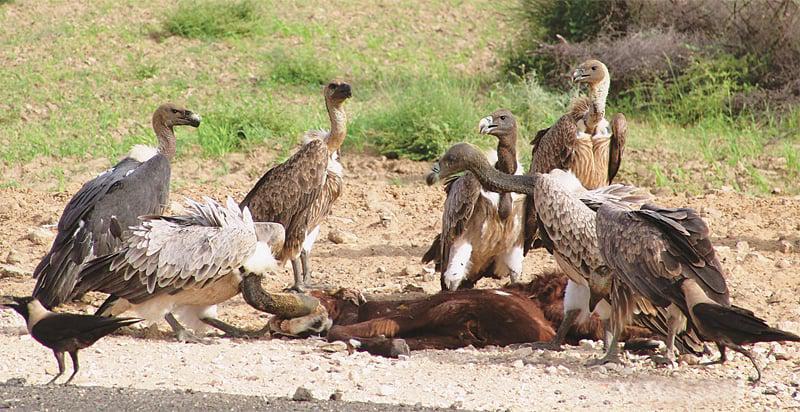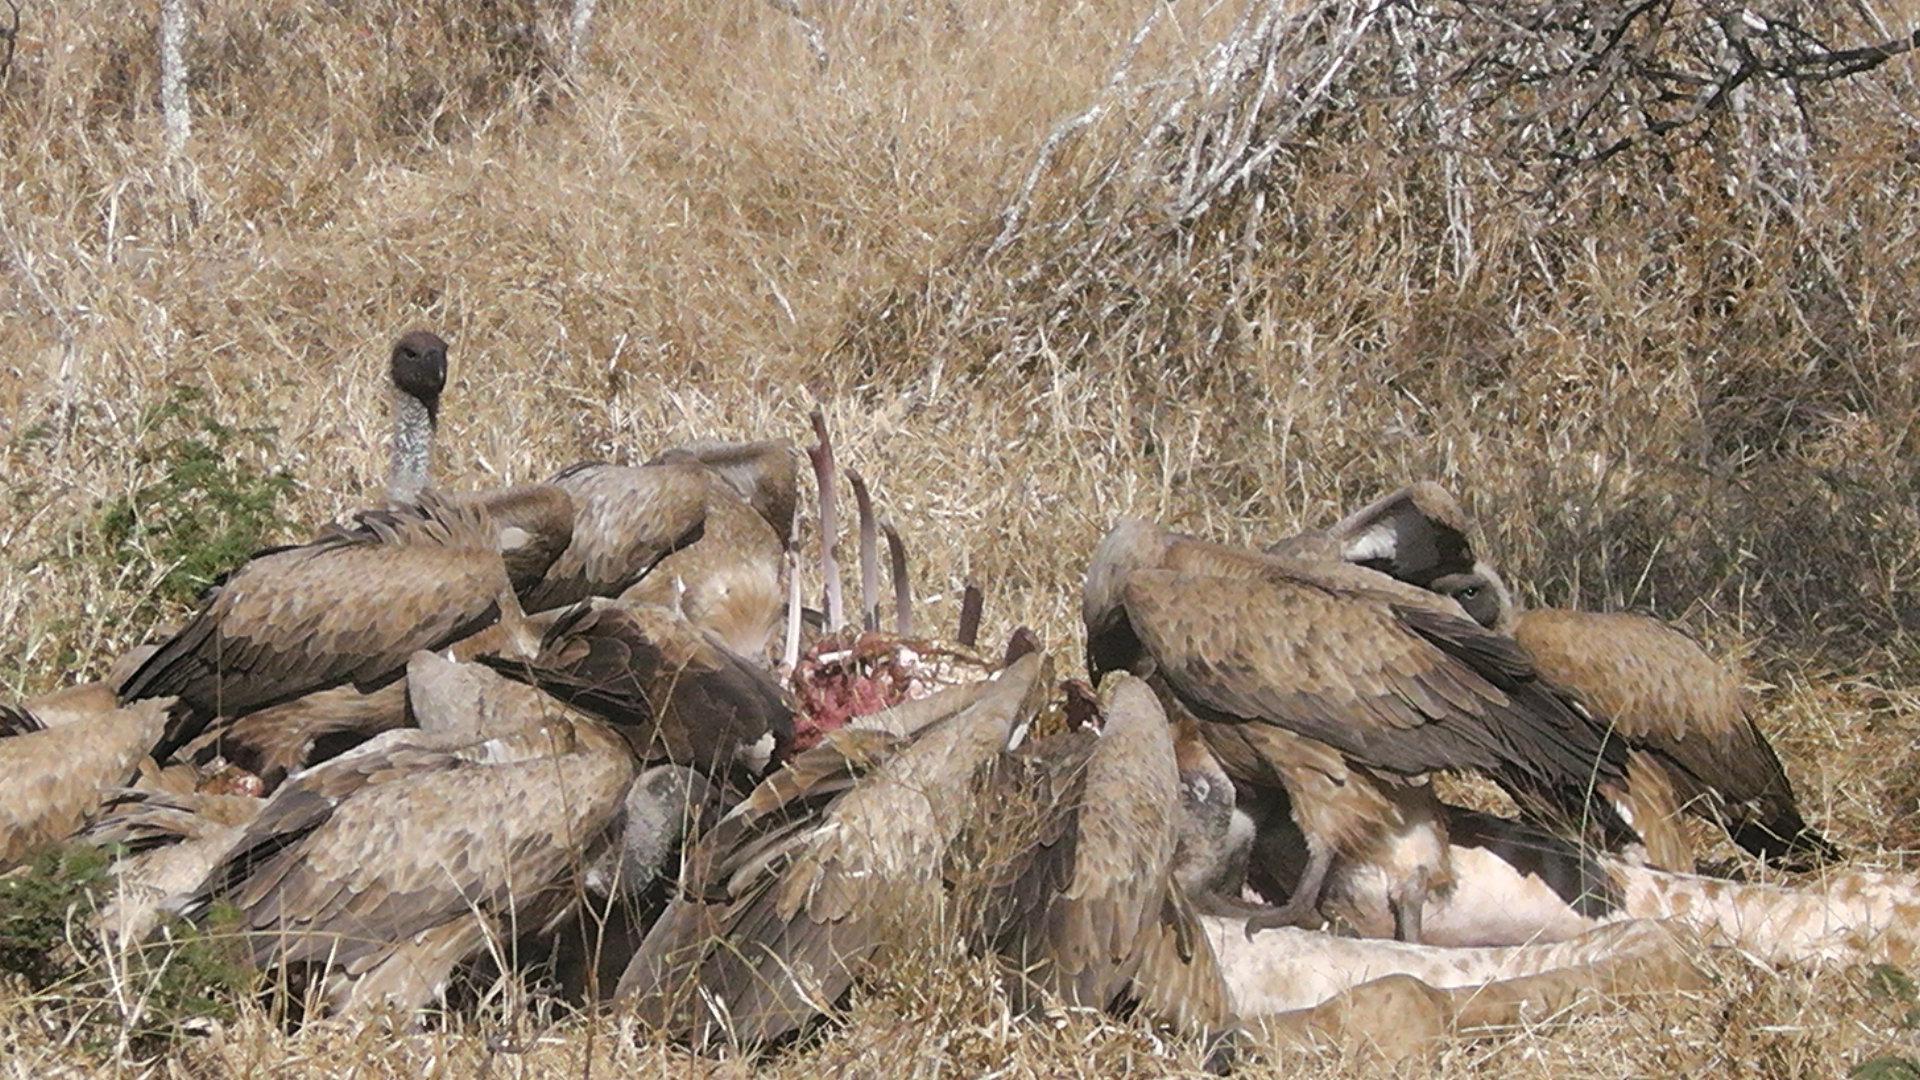The first image is the image on the left, the second image is the image on the right. Considering the images on both sides, is "At least one image shows an apparently living mammal surrounded by vultures." valid? Answer yes or no. No. The first image is the image on the left, the second image is the image on the right. Considering the images on both sides, is "There are two kinds of bird in the image on the left." valid? Answer yes or no. Yes. 